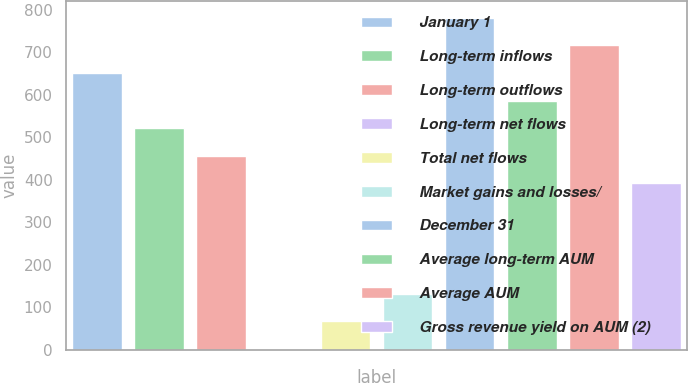Convert chart. <chart><loc_0><loc_0><loc_500><loc_500><bar_chart><fcel>January 1<fcel>Long-term inflows<fcel>Long-term outflows<fcel>Long-term net flows<fcel>Total net flows<fcel>Market gains and losses/<fcel>December 31<fcel>Average long-term AUM<fcel>Average AUM<fcel>Gross revenue yield on AUM (2)<nl><fcel>651<fcel>521.22<fcel>456.33<fcel>2.1<fcel>66.99<fcel>131.88<fcel>780.78<fcel>586.11<fcel>715.89<fcel>391.44<nl></chart> 